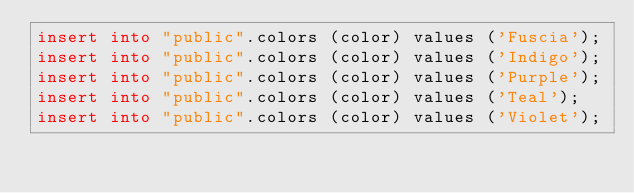<code> <loc_0><loc_0><loc_500><loc_500><_SQL_>insert into "public".colors (color) values ('Fuscia');
insert into "public".colors (color) values ('Indigo');
insert into "public".colors (color) values ('Purple');
insert into "public".colors (color) values ('Teal');
insert into "public".colors (color) values ('Violet');</code> 